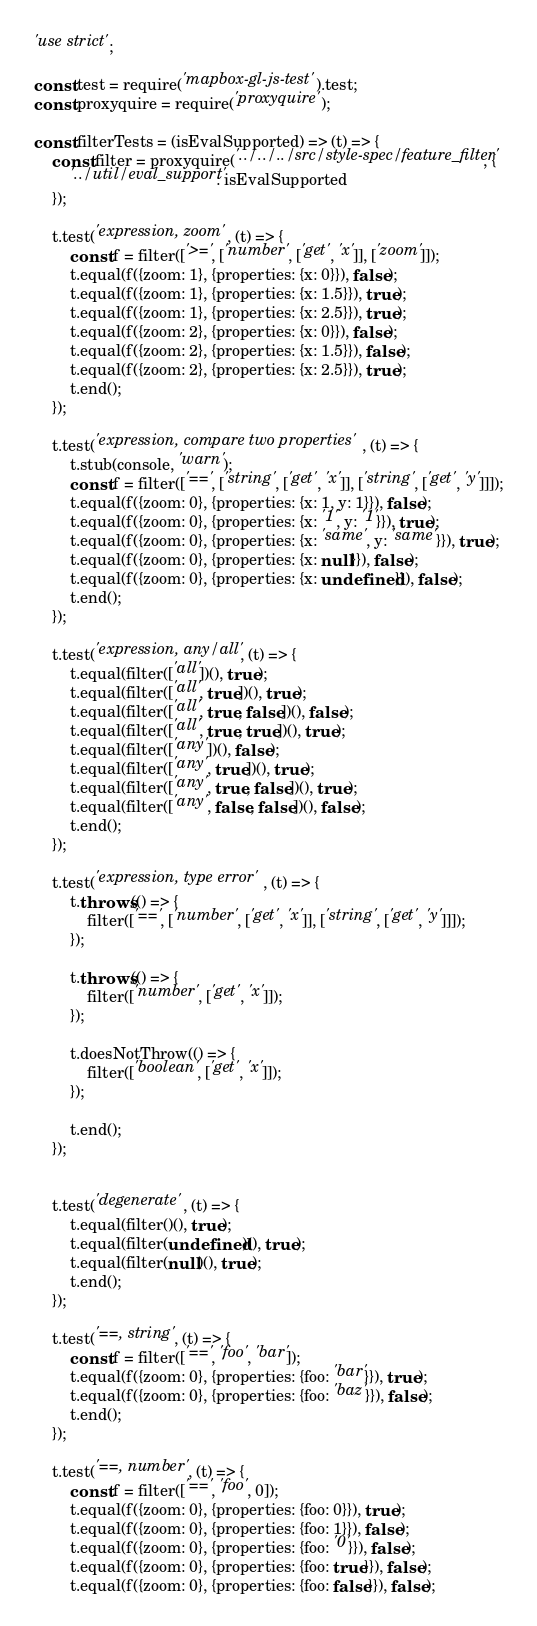Convert code to text. <code><loc_0><loc_0><loc_500><loc_500><_JavaScript_>'use strict';

const test = require('mapbox-gl-js-test').test;
const proxyquire = require('proxyquire');

const filterTests = (isEvalSupported) => (t) => {
    const filter = proxyquire('../../../src/style-spec/feature_filter', {
        '../util/eval_support': isEvalSupported
    });

    t.test('expression, zoom', (t) => {
        const f = filter(['>=', ['number', ['get', 'x']], ['zoom']]);
        t.equal(f({zoom: 1}, {properties: {x: 0}}), false);
        t.equal(f({zoom: 1}, {properties: {x: 1.5}}), true);
        t.equal(f({zoom: 1}, {properties: {x: 2.5}}), true);
        t.equal(f({zoom: 2}, {properties: {x: 0}}), false);
        t.equal(f({zoom: 2}, {properties: {x: 1.5}}), false);
        t.equal(f({zoom: 2}, {properties: {x: 2.5}}), true);
        t.end();
    });

    t.test('expression, compare two properties', (t) => {
        t.stub(console, 'warn');
        const f = filter(['==', ['string', ['get', 'x']], ['string', ['get', 'y']]]);
        t.equal(f({zoom: 0}, {properties: {x: 1, y: 1}}), false);
        t.equal(f({zoom: 0}, {properties: {x: '1', y: '1'}}), true);
        t.equal(f({zoom: 0}, {properties: {x: 'same', y: 'same'}}), true);
        t.equal(f({zoom: 0}, {properties: {x: null}}), false);
        t.equal(f({zoom: 0}, {properties: {x: undefined}}), false);
        t.end();
    });

    t.test('expression, any/all', (t) => {
        t.equal(filter(['all'])(), true);
        t.equal(filter(['all', true])(), true);
        t.equal(filter(['all', true, false])(), false);
        t.equal(filter(['all', true, true])(), true);
        t.equal(filter(['any'])(), false);
        t.equal(filter(['any', true])(), true);
        t.equal(filter(['any', true, false])(), true);
        t.equal(filter(['any', false, false])(), false);
        t.end();
    });

    t.test('expression, type error', (t) => {
        t.throws(() => {
            filter(['==', ['number', ['get', 'x']], ['string', ['get', 'y']]]);
        });

        t.throws(() => {
            filter(['number', ['get', 'x']]);
        });

        t.doesNotThrow(() => {
            filter(['boolean', ['get', 'x']]);
        });

        t.end();
    });


    t.test('degenerate', (t) => {
        t.equal(filter()(), true);
        t.equal(filter(undefined)(), true);
        t.equal(filter(null)(), true);
        t.end();
    });

    t.test('==, string', (t) => {
        const f = filter(['==', 'foo', 'bar']);
        t.equal(f({zoom: 0}, {properties: {foo: 'bar'}}), true);
        t.equal(f({zoom: 0}, {properties: {foo: 'baz'}}), false);
        t.end();
    });

    t.test('==, number', (t) => {
        const f = filter(['==', 'foo', 0]);
        t.equal(f({zoom: 0}, {properties: {foo: 0}}), true);
        t.equal(f({zoom: 0}, {properties: {foo: 1}}), false);
        t.equal(f({zoom: 0}, {properties: {foo: '0'}}), false);
        t.equal(f({zoom: 0}, {properties: {foo: true}}), false);
        t.equal(f({zoom: 0}, {properties: {foo: false}}), false);</code> 